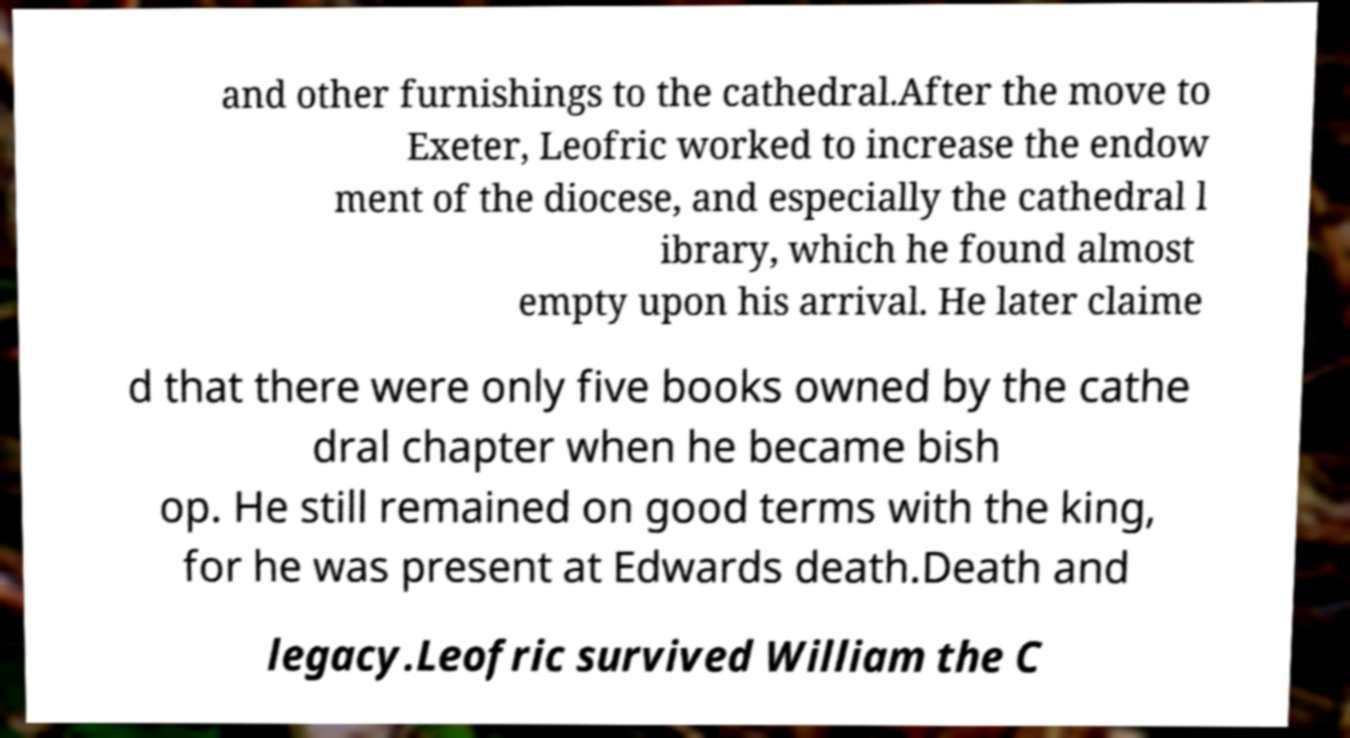Can you read and provide the text displayed in the image?This photo seems to have some interesting text. Can you extract and type it out for me? and other furnishings to the cathedral.After the move to Exeter, Leofric worked to increase the endow ment of the diocese, and especially the cathedral l ibrary, which he found almost empty upon his arrival. He later claime d that there were only five books owned by the cathe dral chapter when he became bish op. He still remained on good terms with the king, for he was present at Edwards death.Death and legacy.Leofric survived William the C 